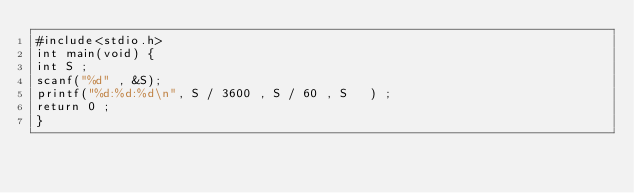Convert code to text. <code><loc_0><loc_0><loc_500><loc_500><_C_>#include<stdio.h>
int main(void) {
int S ;
scanf("%d" , &S);
printf("%d:%d:%d\n", S / 3600 , S / 60 , S   ) ;
return 0 ;
}</code> 